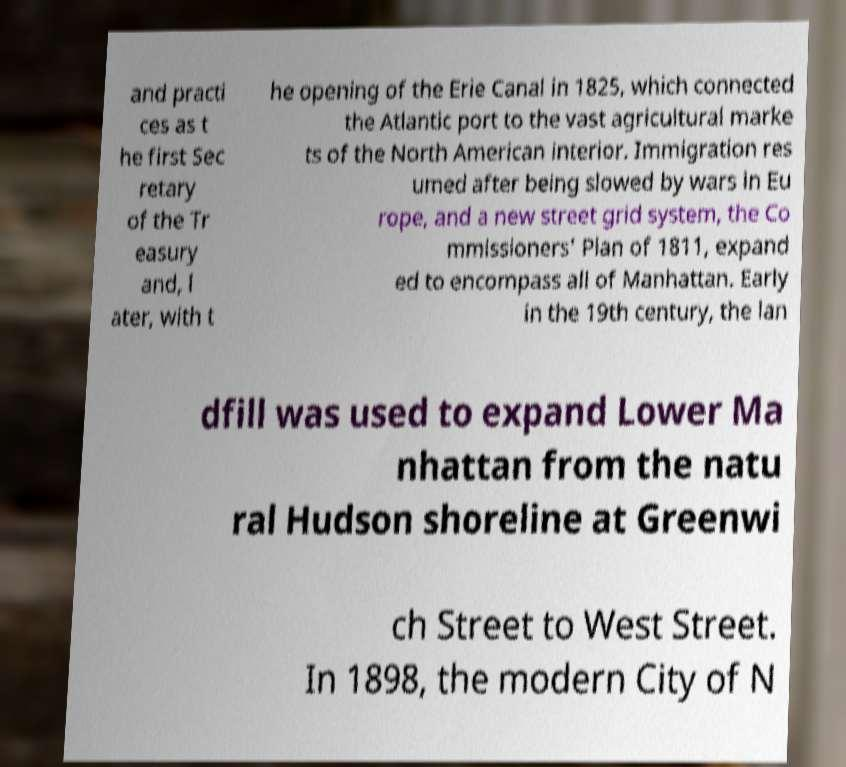Could you extract and type out the text from this image? and practi ces as t he first Sec retary of the Tr easury and, l ater, with t he opening of the Erie Canal in 1825, which connected the Atlantic port to the vast agricultural marke ts of the North American interior. Immigration res umed after being slowed by wars in Eu rope, and a new street grid system, the Co mmissioners' Plan of 1811, expand ed to encompass all of Manhattan. Early in the 19th century, the lan dfill was used to expand Lower Ma nhattan from the natu ral Hudson shoreline at Greenwi ch Street to West Street. In 1898, the modern City of N 